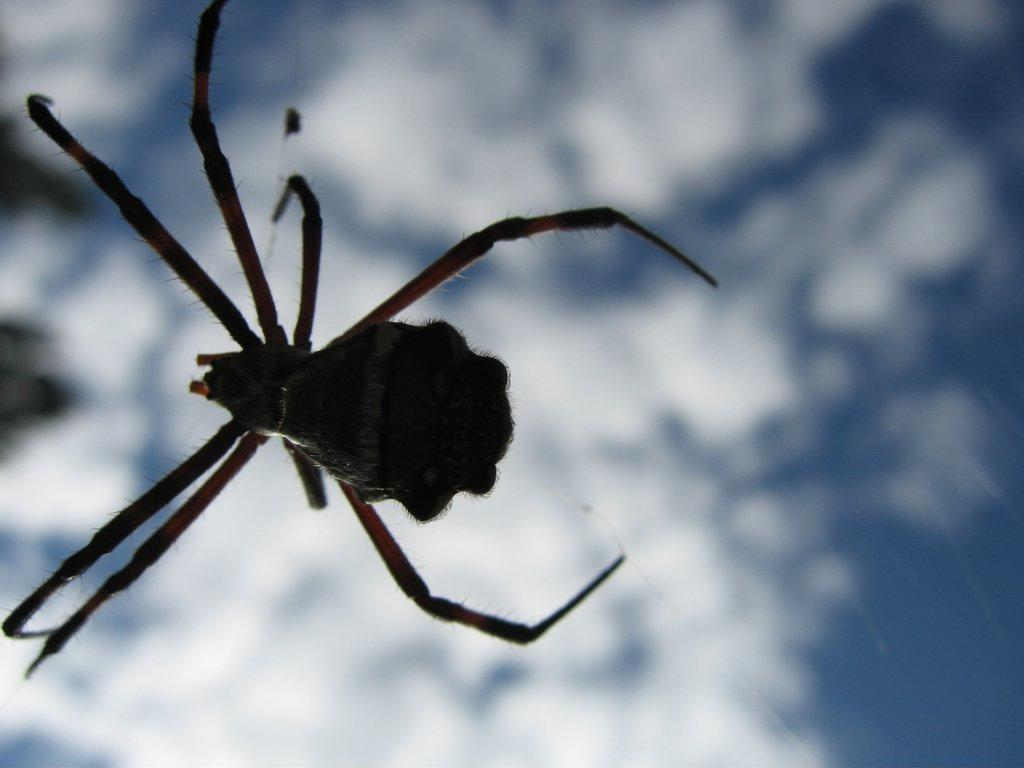What is the main subject of the image? There is a spider in the image. Where is the spider located? The spider is on a web. What can be seen in the background of the image? The sky is visible in the image. How would you describe the sky in the image? The sky appears to be cloudy. How many beans are present in the image? There are no beans present in the image. 